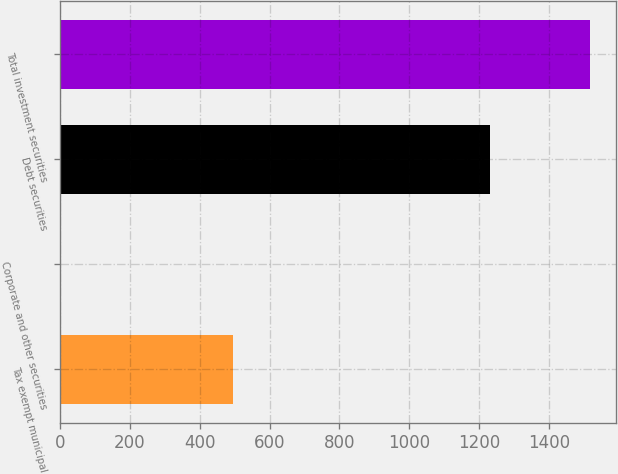Convert chart. <chart><loc_0><loc_0><loc_500><loc_500><bar_chart><fcel>Tax exempt municipal<fcel>Corporate and other securities<fcel>Debt securities<fcel>Total investment securities<nl><fcel>494<fcel>4<fcel>1232<fcel>1517<nl></chart> 